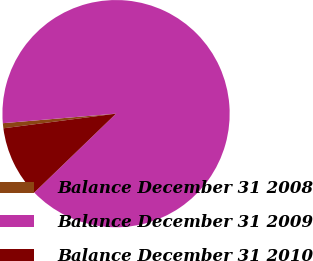Convert chart to OTSL. <chart><loc_0><loc_0><loc_500><loc_500><pie_chart><fcel>Balance December 31 2008<fcel>Balance December 31 2009<fcel>Balance December 31 2010<nl><fcel>0.72%<fcel>89.12%<fcel>10.16%<nl></chart> 